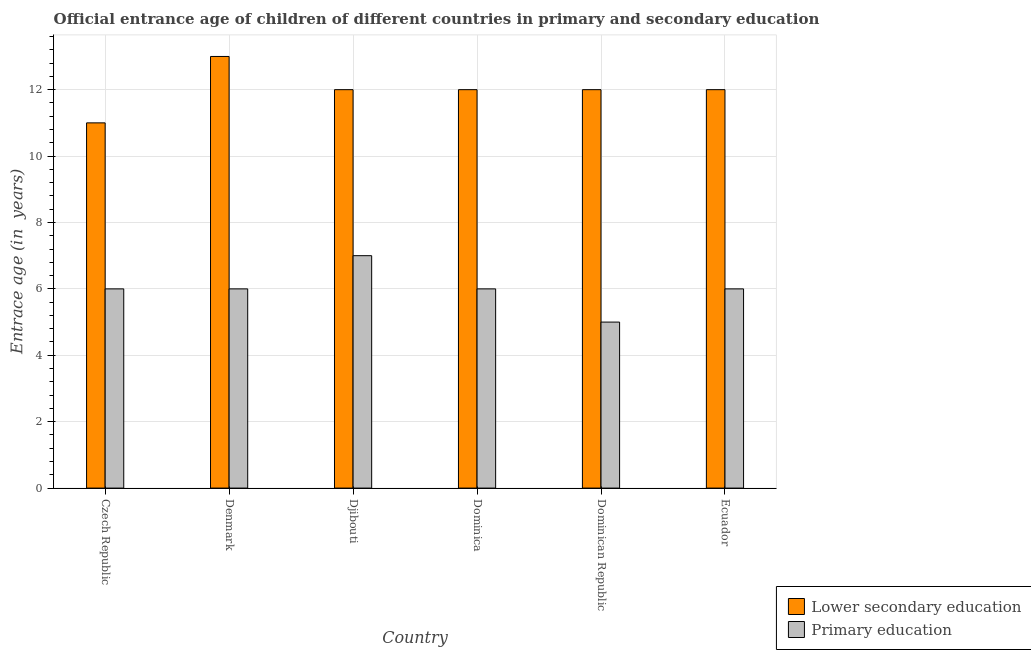How many different coloured bars are there?
Offer a terse response. 2. How many groups of bars are there?
Make the answer very short. 6. How many bars are there on the 4th tick from the right?
Give a very brief answer. 2. In how many cases, is the number of bars for a given country not equal to the number of legend labels?
Ensure brevity in your answer.  0. Across all countries, what is the maximum entrance age of chiildren in primary education?
Provide a short and direct response. 7. Across all countries, what is the minimum entrance age of chiildren in primary education?
Keep it short and to the point. 5. In which country was the entrance age of chiildren in primary education minimum?
Offer a terse response. Dominican Republic. What is the total entrance age of children in lower secondary education in the graph?
Make the answer very short. 72. What is the difference between the entrance age of children in lower secondary education in Dominican Republic and that in Ecuador?
Your answer should be very brief. 0. What is the difference between the entrance age of children in lower secondary education in Djibouti and the entrance age of chiildren in primary education in Czech Republic?
Provide a short and direct response. 6. What is the average entrance age of children in lower secondary education per country?
Your answer should be compact. 12. What is the difference between the entrance age of children in lower secondary education and entrance age of chiildren in primary education in Dominican Republic?
Give a very brief answer. 7. In how many countries, is the entrance age of children in lower secondary education greater than 12.8 years?
Give a very brief answer. 1. What is the ratio of the entrance age of children in lower secondary education in Czech Republic to that in Dominican Republic?
Provide a short and direct response. 0.92. What is the difference between the highest and the lowest entrance age of children in lower secondary education?
Ensure brevity in your answer.  2. What does the 1st bar from the left in Djibouti represents?
Offer a terse response. Lower secondary education. What does the 1st bar from the right in Djibouti represents?
Offer a very short reply. Primary education. How many bars are there?
Your answer should be very brief. 12. Are all the bars in the graph horizontal?
Keep it short and to the point. No. What is the difference between two consecutive major ticks on the Y-axis?
Offer a terse response. 2. Are the values on the major ticks of Y-axis written in scientific E-notation?
Make the answer very short. No. Does the graph contain any zero values?
Make the answer very short. No. What is the title of the graph?
Offer a very short reply. Official entrance age of children of different countries in primary and secondary education. Does "Public credit registry" appear as one of the legend labels in the graph?
Provide a succinct answer. No. What is the label or title of the Y-axis?
Keep it short and to the point. Entrace age (in  years). What is the Entrace age (in  years) in Primary education in Denmark?
Make the answer very short. 6. What is the Entrace age (in  years) of Lower secondary education in Djibouti?
Offer a very short reply. 12. What is the Entrace age (in  years) of Primary education in Djibouti?
Offer a terse response. 7. What is the Entrace age (in  years) of Lower secondary education in Dominica?
Offer a very short reply. 12. What is the Entrace age (in  years) in Primary education in Dominica?
Ensure brevity in your answer.  6. What is the Entrace age (in  years) in Lower secondary education in Ecuador?
Give a very brief answer. 12. Across all countries, what is the maximum Entrace age (in  years) of Lower secondary education?
Ensure brevity in your answer.  13. Across all countries, what is the minimum Entrace age (in  years) of Lower secondary education?
Provide a short and direct response. 11. Across all countries, what is the minimum Entrace age (in  years) in Primary education?
Make the answer very short. 5. What is the difference between the Entrace age (in  years) of Primary education in Czech Republic and that in Denmark?
Your response must be concise. 0. What is the difference between the Entrace age (in  years) of Lower secondary education in Czech Republic and that in Djibouti?
Keep it short and to the point. -1. What is the difference between the Entrace age (in  years) of Lower secondary education in Czech Republic and that in Dominican Republic?
Offer a terse response. -1. What is the difference between the Entrace age (in  years) of Primary education in Czech Republic and that in Dominican Republic?
Ensure brevity in your answer.  1. What is the difference between the Entrace age (in  years) in Lower secondary education in Czech Republic and that in Ecuador?
Your answer should be very brief. -1. What is the difference between the Entrace age (in  years) of Lower secondary education in Denmark and that in Djibouti?
Your answer should be very brief. 1. What is the difference between the Entrace age (in  years) of Lower secondary education in Denmark and that in Dominica?
Offer a terse response. 1. What is the difference between the Entrace age (in  years) in Primary education in Denmark and that in Dominican Republic?
Offer a terse response. 1. What is the difference between the Entrace age (in  years) in Primary education in Denmark and that in Ecuador?
Give a very brief answer. 0. What is the difference between the Entrace age (in  years) in Lower secondary education in Djibouti and that in Dominica?
Keep it short and to the point. 0. What is the difference between the Entrace age (in  years) in Primary education in Djibouti and that in Dominica?
Give a very brief answer. 1. What is the difference between the Entrace age (in  years) in Lower secondary education in Djibouti and that in Dominican Republic?
Keep it short and to the point. 0. What is the difference between the Entrace age (in  years) of Lower secondary education in Djibouti and that in Ecuador?
Provide a short and direct response. 0. What is the difference between the Entrace age (in  years) in Primary education in Djibouti and that in Ecuador?
Make the answer very short. 1. What is the difference between the Entrace age (in  years) in Lower secondary education in Dominica and that in Dominican Republic?
Give a very brief answer. 0. What is the difference between the Entrace age (in  years) in Primary education in Dominica and that in Dominican Republic?
Offer a terse response. 1. What is the difference between the Entrace age (in  years) of Lower secondary education in Dominican Republic and that in Ecuador?
Keep it short and to the point. 0. What is the difference between the Entrace age (in  years) in Lower secondary education in Czech Republic and the Entrace age (in  years) in Primary education in Djibouti?
Give a very brief answer. 4. What is the difference between the Entrace age (in  years) of Lower secondary education in Czech Republic and the Entrace age (in  years) of Primary education in Dominican Republic?
Your response must be concise. 6. What is the difference between the Entrace age (in  years) in Lower secondary education in Czech Republic and the Entrace age (in  years) in Primary education in Ecuador?
Make the answer very short. 5. What is the difference between the Entrace age (in  years) in Lower secondary education in Denmark and the Entrace age (in  years) in Primary education in Dominican Republic?
Give a very brief answer. 8. What is the difference between the Entrace age (in  years) of Lower secondary education in Djibouti and the Entrace age (in  years) of Primary education in Dominica?
Provide a succinct answer. 6. What is the difference between the Entrace age (in  years) of Lower secondary education in Djibouti and the Entrace age (in  years) of Primary education in Dominican Republic?
Offer a very short reply. 7. What is the difference between the Entrace age (in  years) in Lower secondary education in Djibouti and the Entrace age (in  years) in Primary education in Ecuador?
Offer a very short reply. 6. What is the difference between the Entrace age (in  years) in Lower secondary education in Dominica and the Entrace age (in  years) in Primary education in Dominican Republic?
Give a very brief answer. 7. What is the difference between the Entrace age (in  years) in Lower secondary education in Dominican Republic and the Entrace age (in  years) in Primary education in Ecuador?
Make the answer very short. 6. What is the average Entrace age (in  years) in Lower secondary education per country?
Offer a very short reply. 12. What is the difference between the Entrace age (in  years) of Lower secondary education and Entrace age (in  years) of Primary education in Djibouti?
Offer a very short reply. 5. What is the difference between the Entrace age (in  years) in Lower secondary education and Entrace age (in  years) in Primary education in Dominican Republic?
Give a very brief answer. 7. What is the difference between the Entrace age (in  years) in Lower secondary education and Entrace age (in  years) in Primary education in Ecuador?
Your response must be concise. 6. What is the ratio of the Entrace age (in  years) in Lower secondary education in Czech Republic to that in Denmark?
Your answer should be very brief. 0.85. What is the ratio of the Entrace age (in  years) in Lower secondary education in Czech Republic to that in Dominica?
Offer a terse response. 0.92. What is the ratio of the Entrace age (in  years) of Primary education in Czech Republic to that in Dominica?
Your answer should be compact. 1. What is the ratio of the Entrace age (in  years) of Primary education in Czech Republic to that in Dominican Republic?
Keep it short and to the point. 1.2. What is the ratio of the Entrace age (in  years) of Lower secondary education in Denmark to that in Djibouti?
Make the answer very short. 1.08. What is the ratio of the Entrace age (in  years) in Primary education in Denmark to that in Dominica?
Give a very brief answer. 1. What is the ratio of the Entrace age (in  years) of Lower secondary education in Djibouti to that in Ecuador?
Ensure brevity in your answer.  1. What is the ratio of the Entrace age (in  years) of Primary education in Djibouti to that in Ecuador?
Your answer should be very brief. 1.17. What is the ratio of the Entrace age (in  years) of Lower secondary education in Dominica to that in Dominican Republic?
Provide a succinct answer. 1. What is the ratio of the Entrace age (in  years) in Lower secondary education in Dominica to that in Ecuador?
Make the answer very short. 1. What is the ratio of the Entrace age (in  years) in Lower secondary education in Dominican Republic to that in Ecuador?
Your answer should be compact. 1. What is the ratio of the Entrace age (in  years) of Primary education in Dominican Republic to that in Ecuador?
Your answer should be compact. 0.83. What is the difference between the highest and the second highest Entrace age (in  years) of Lower secondary education?
Give a very brief answer. 1. What is the difference between the highest and the lowest Entrace age (in  years) in Lower secondary education?
Offer a very short reply. 2. What is the difference between the highest and the lowest Entrace age (in  years) in Primary education?
Offer a very short reply. 2. 